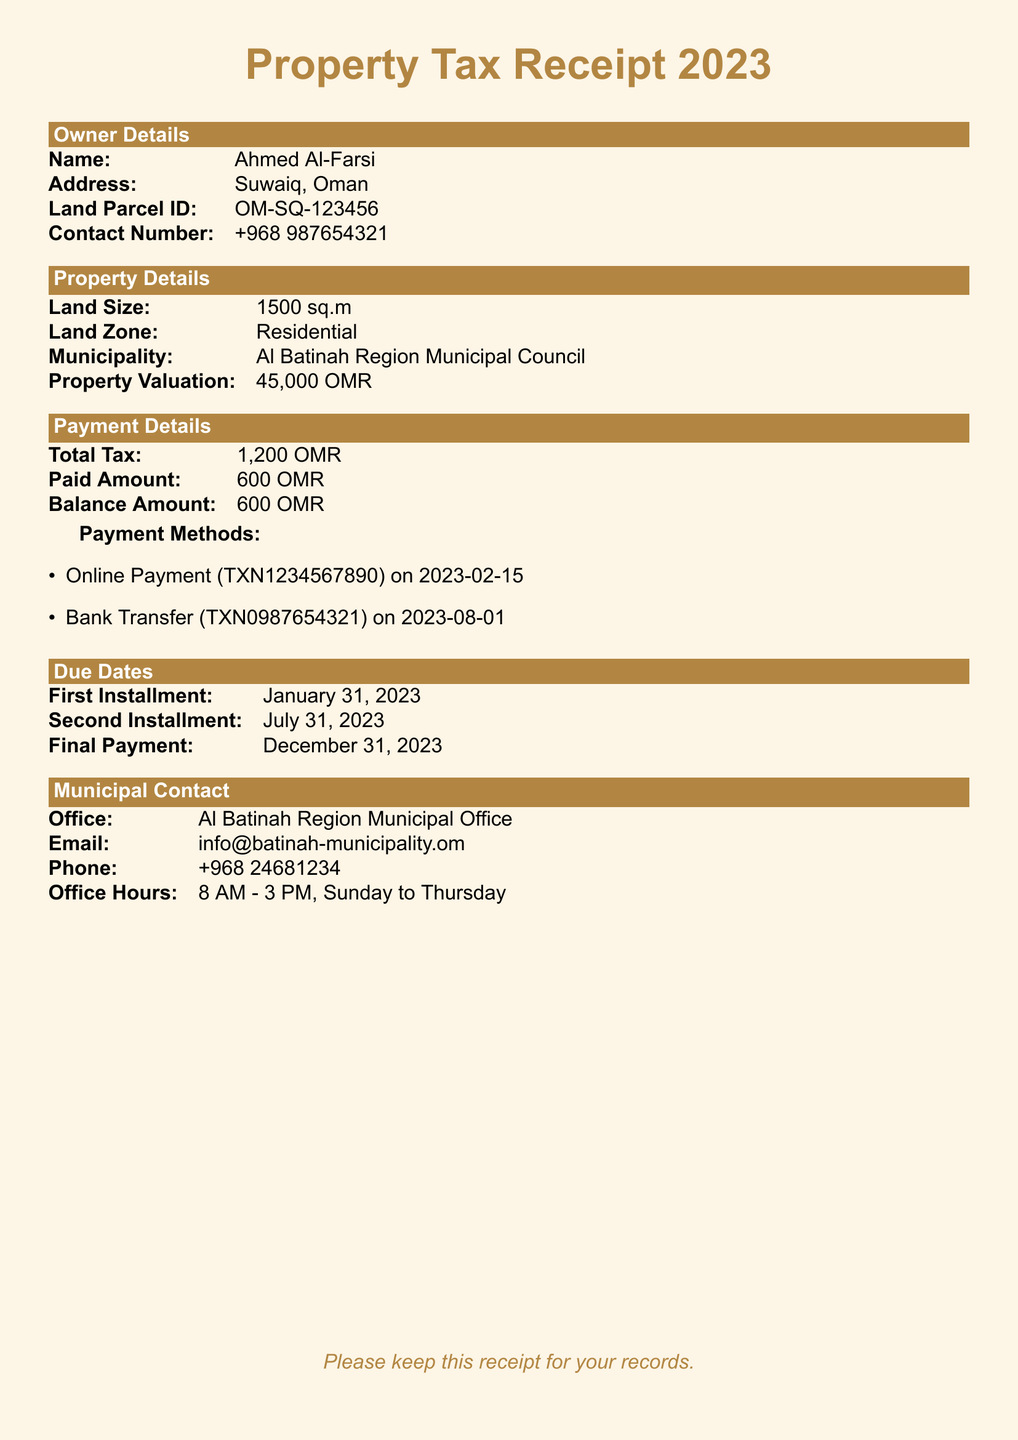What is the total tax amount? The total tax amount is stated under Payment Details in the document.
Answer: 1,200 OMR What is the balance amount due? The balance amount due is also listed under Payment Details, requiring payment before deadlines.
Answer: 600 OMR What is the land size? The land size is provided in the Property Details section of the document.
Answer: 1500 sq.m When is the final payment due? The due date for the final payment is mentioned under Due Dates.
Answer: December 31, 2023 What payment method was used on February 15, 2023? The payment method details include specific transaction information listed under Payment Methods.
Answer: Online Payment Who is the owner of the property? The owner's name is provided in the Owner Details section at the start of the document.
Answer: Ahmed Al-Farsi What is the municipality office's phone number? The contact number for the municipality office is found in the Municipal Contact section of the document.
Answer: +968 24681234 What is the second installment due date? The due date for the second installment is detailed in the Due Dates section of the document.
Answer: July 31, 2023 What is the property valuation? The property's valuation is listed under Property Details.
Answer: 45,000 OMR 